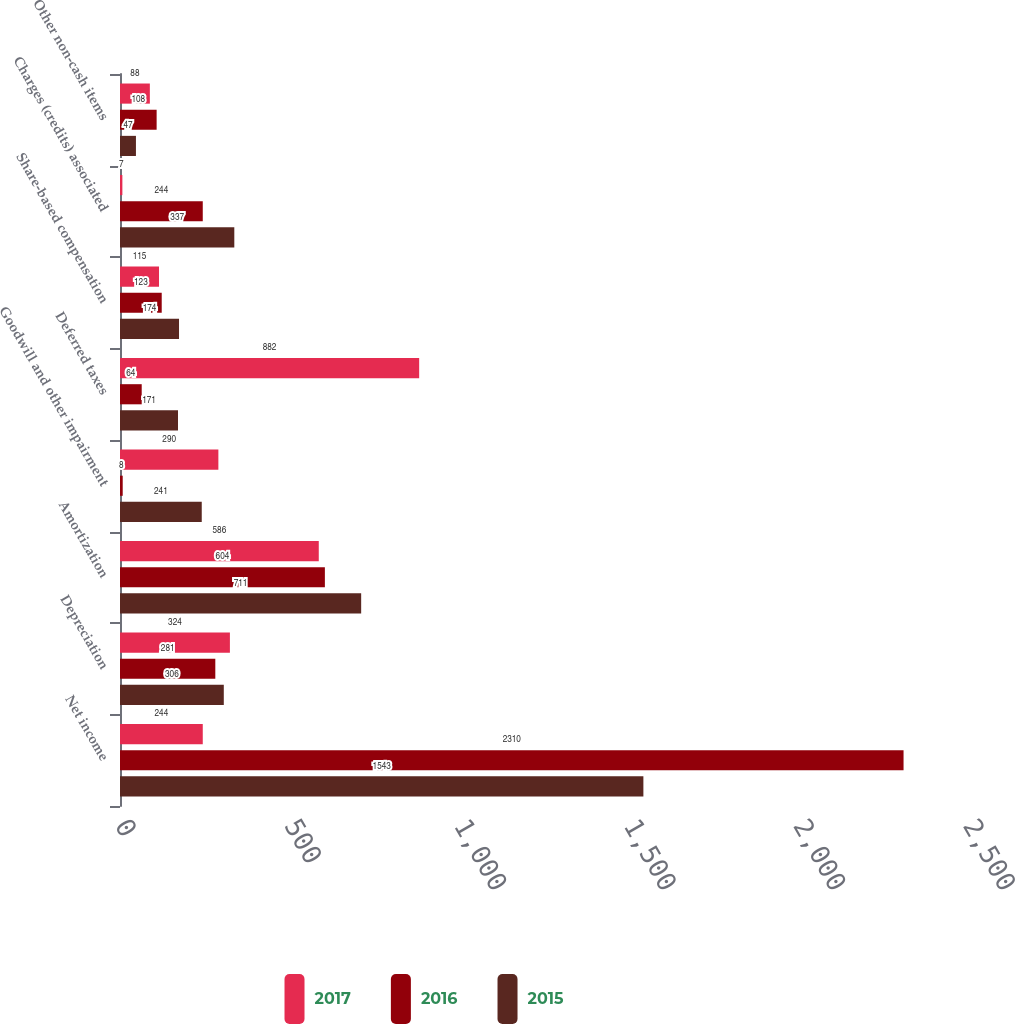Convert chart. <chart><loc_0><loc_0><loc_500><loc_500><stacked_bar_chart><ecel><fcel>Net income<fcel>Depreciation<fcel>Amortization<fcel>Goodwill and other impairment<fcel>Deferred taxes<fcel>Share-based compensation<fcel>Charges (credits) associated<fcel>Other non-cash items<nl><fcel>2017<fcel>244<fcel>324<fcel>586<fcel>290<fcel>882<fcel>115<fcel>7<fcel>88<nl><fcel>2016<fcel>2310<fcel>281<fcel>604<fcel>8<fcel>64<fcel>123<fcel>244<fcel>108<nl><fcel>2015<fcel>1543<fcel>306<fcel>711<fcel>241<fcel>171<fcel>174<fcel>337<fcel>47<nl></chart> 